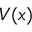Convert formula to latex. <formula><loc_0><loc_0><loc_500><loc_500>V ( x )</formula> 